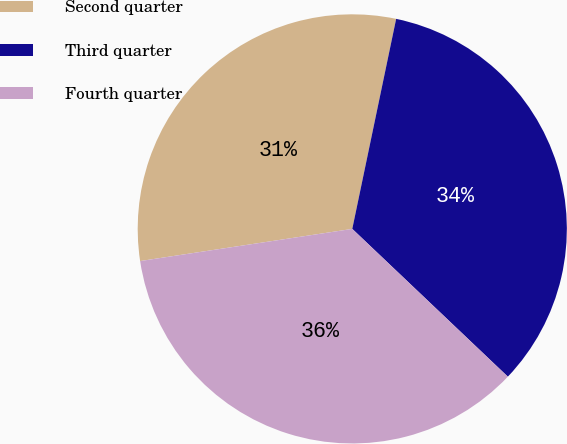Convert chart to OTSL. <chart><loc_0><loc_0><loc_500><loc_500><pie_chart><fcel>Second quarter<fcel>Third quarter<fcel>Fourth quarter<nl><fcel>30.67%<fcel>33.81%<fcel>35.51%<nl></chart> 